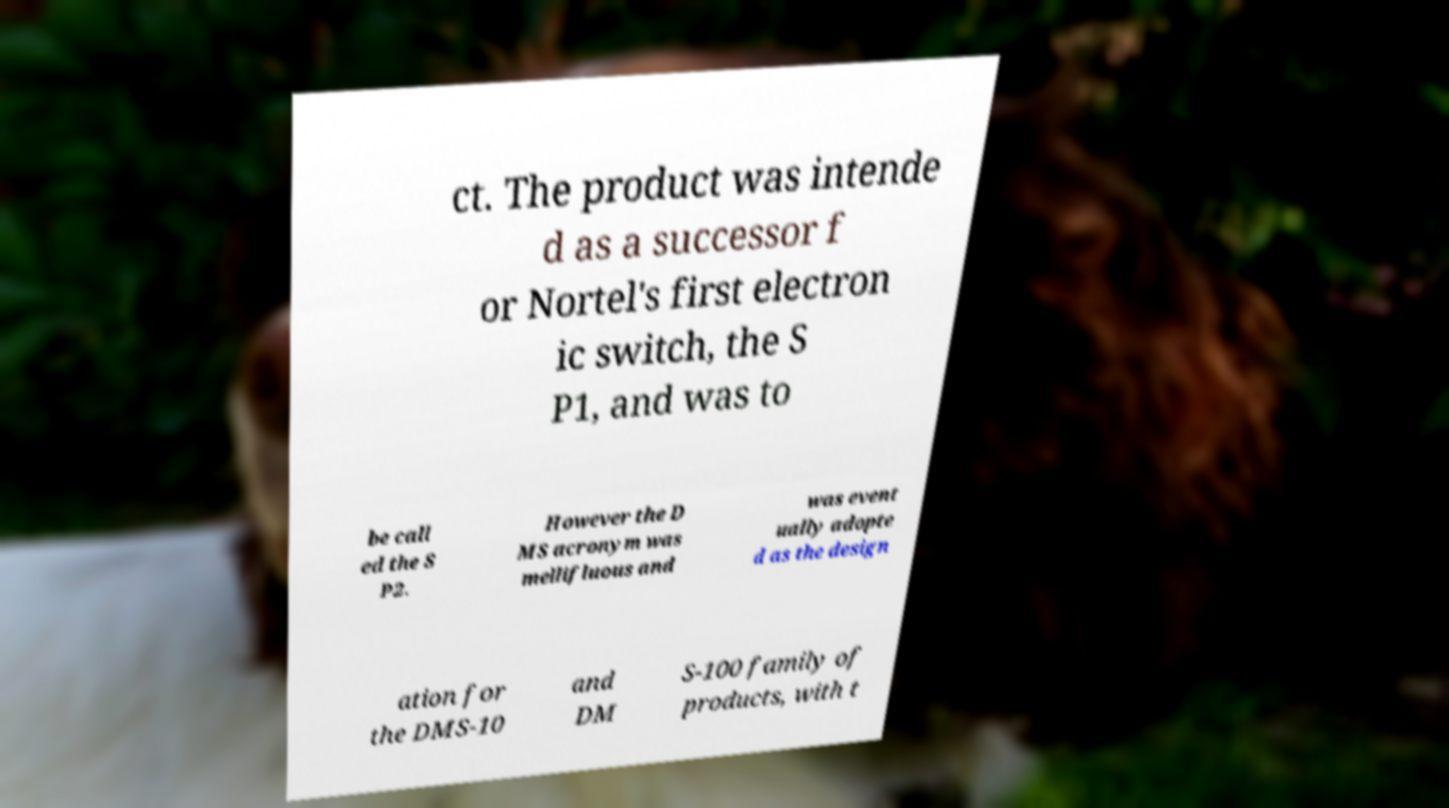Can you read and provide the text displayed in the image?This photo seems to have some interesting text. Can you extract and type it out for me? ct. The product was intende d as a successor f or Nortel's first electron ic switch, the S P1, and was to be call ed the S P2. However the D MS acronym was mellifluous and was event ually adopte d as the design ation for the DMS-10 and DM S-100 family of products, with t 